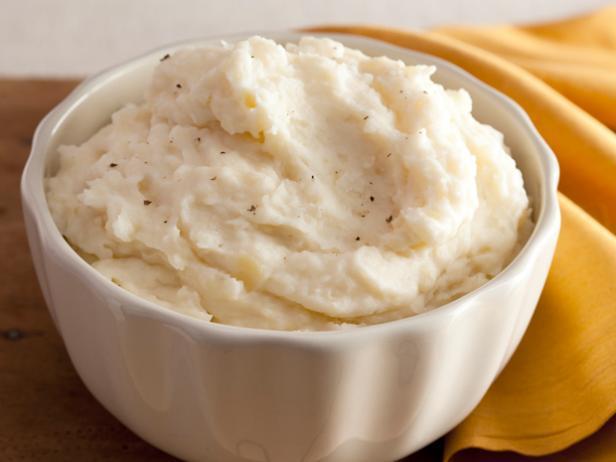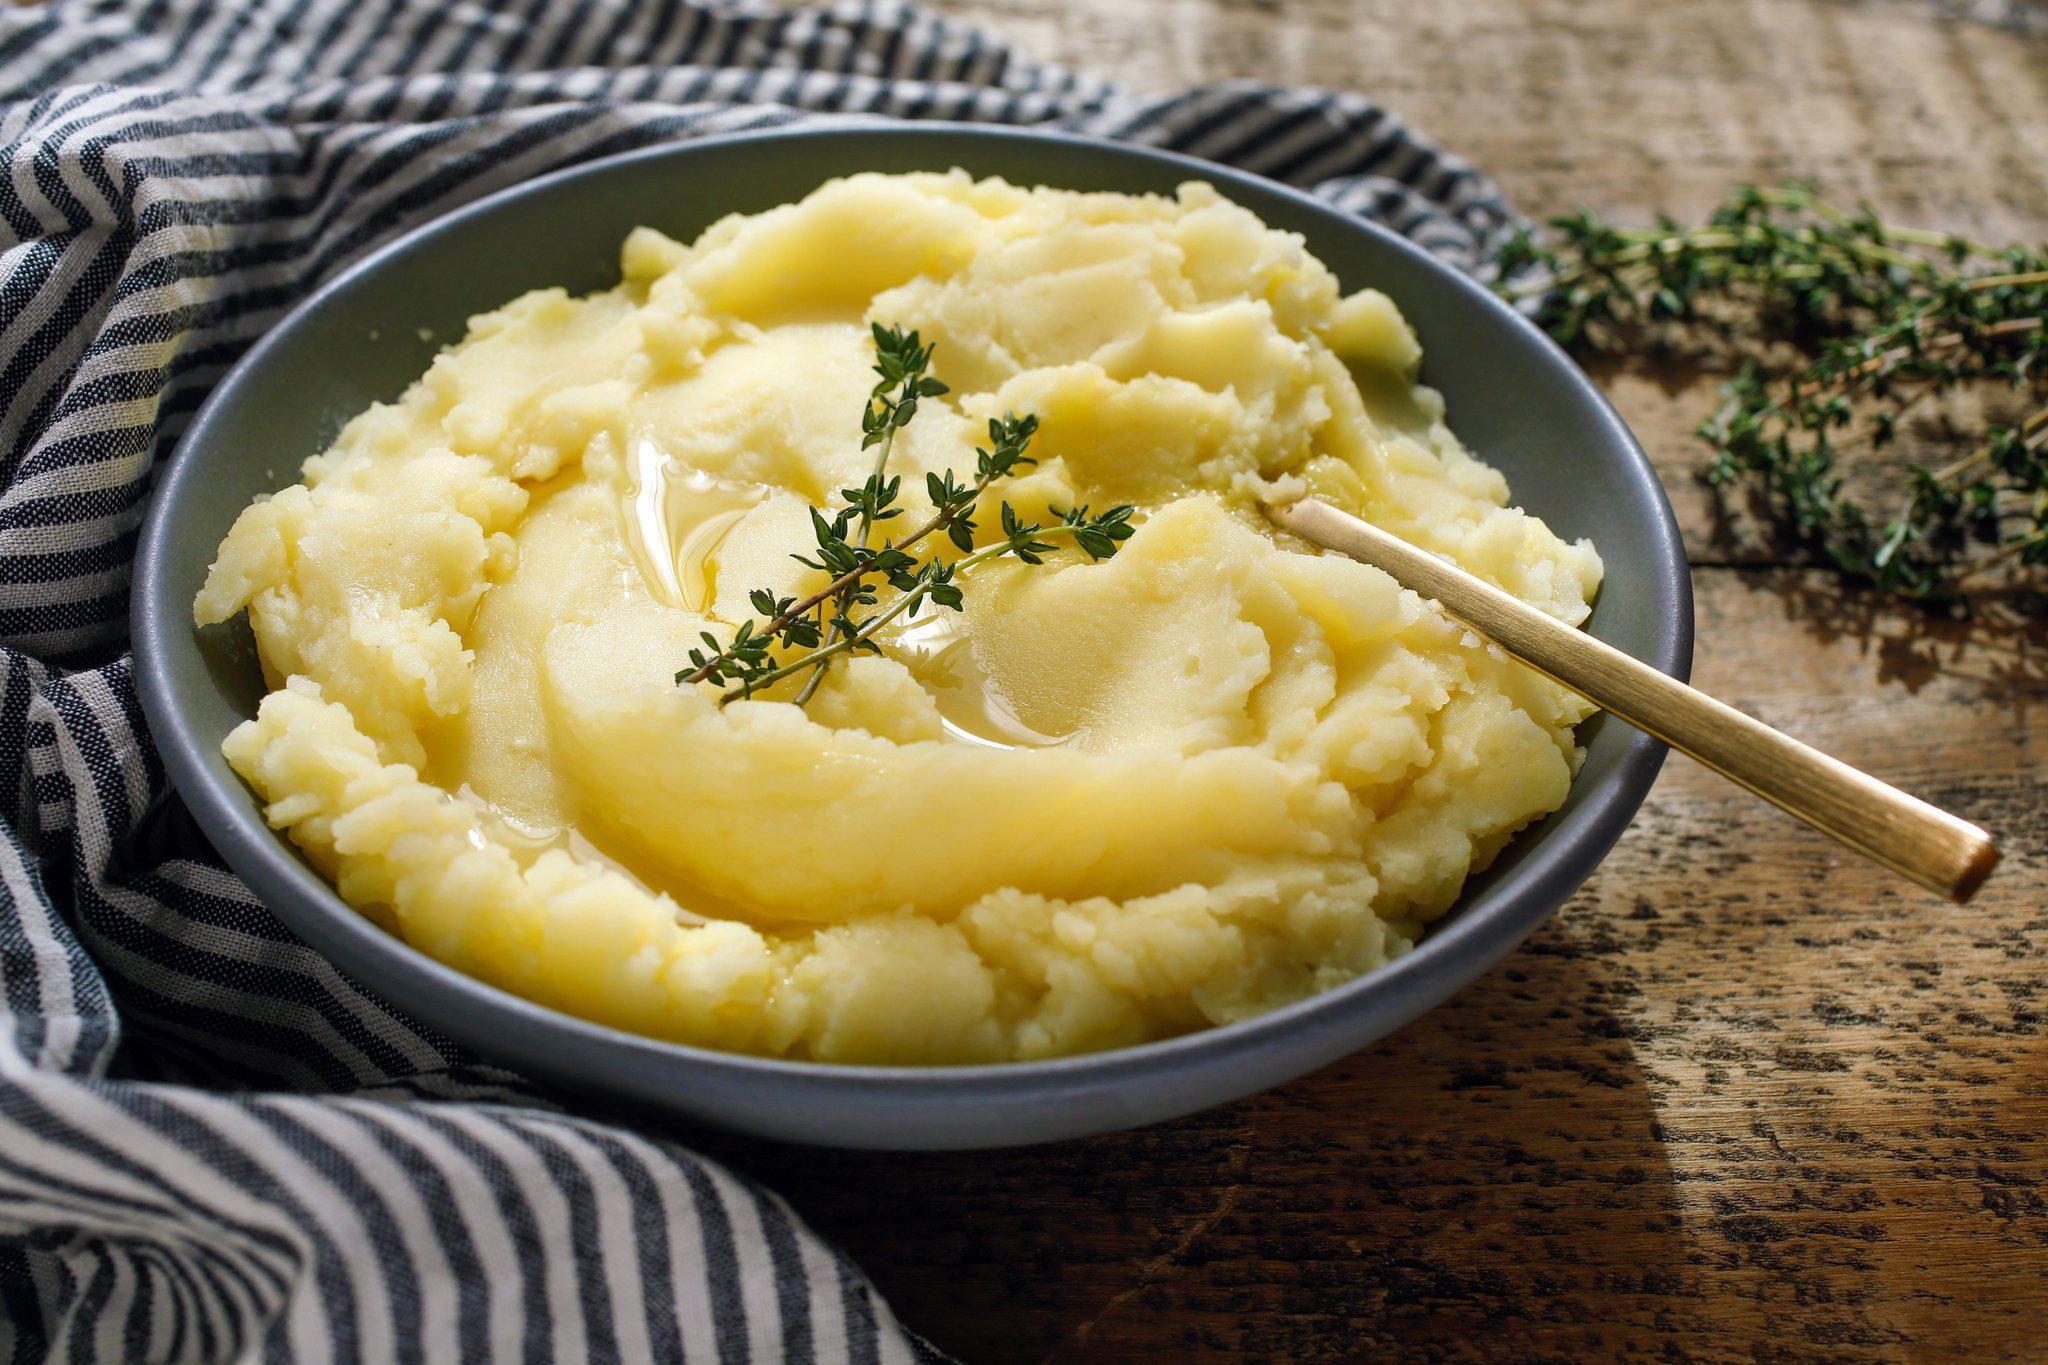The first image is the image on the left, the second image is the image on the right. Evaluate the accuracy of this statement regarding the images: "the bowl on the left image is all white". Is it true? Answer yes or no. Yes. 